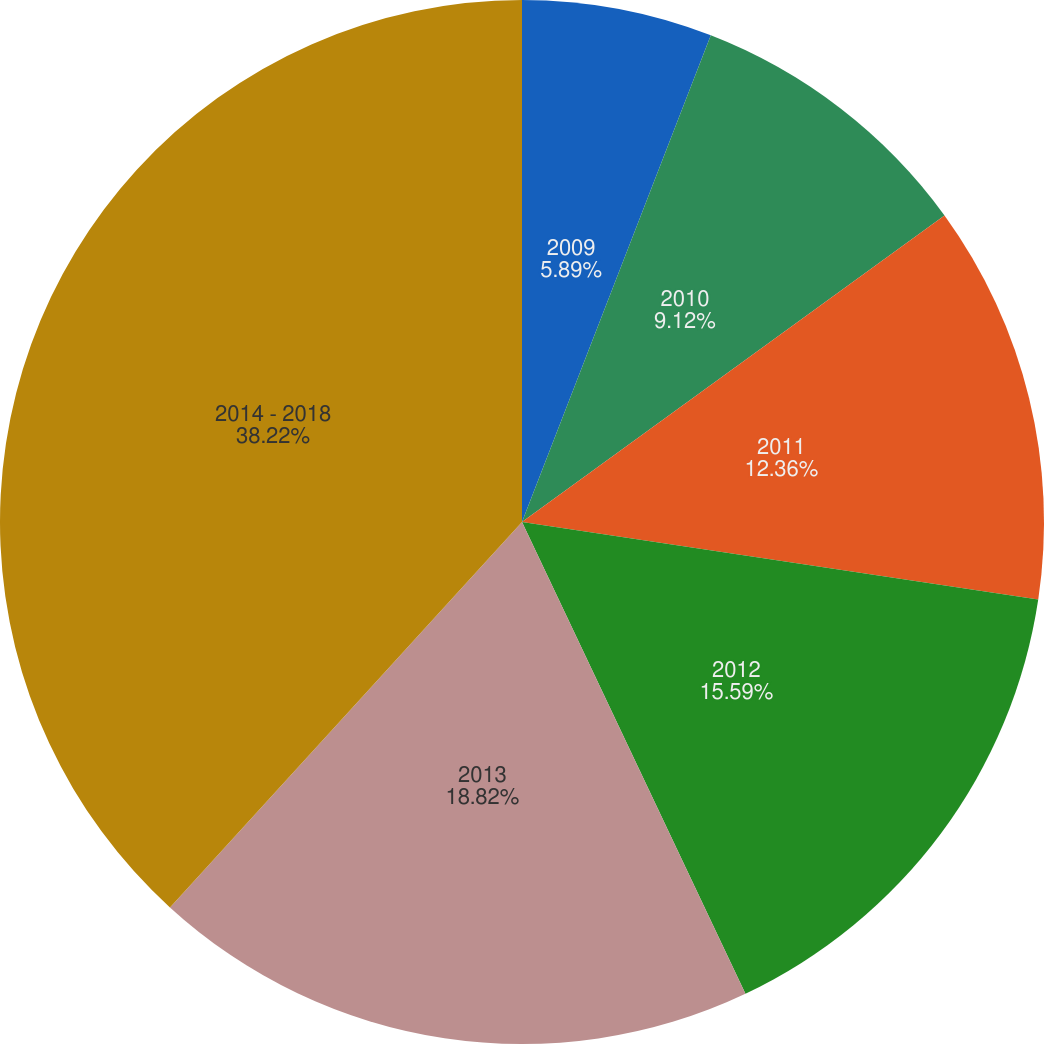Convert chart. <chart><loc_0><loc_0><loc_500><loc_500><pie_chart><fcel>2009<fcel>2010<fcel>2011<fcel>2012<fcel>2013<fcel>2014 - 2018<nl><fcel>5.89%<fcel>9.12%<fcel>12.36%<fcel>15.59%<fcel>18.82%<fcel>38.22%<nl></chart> 